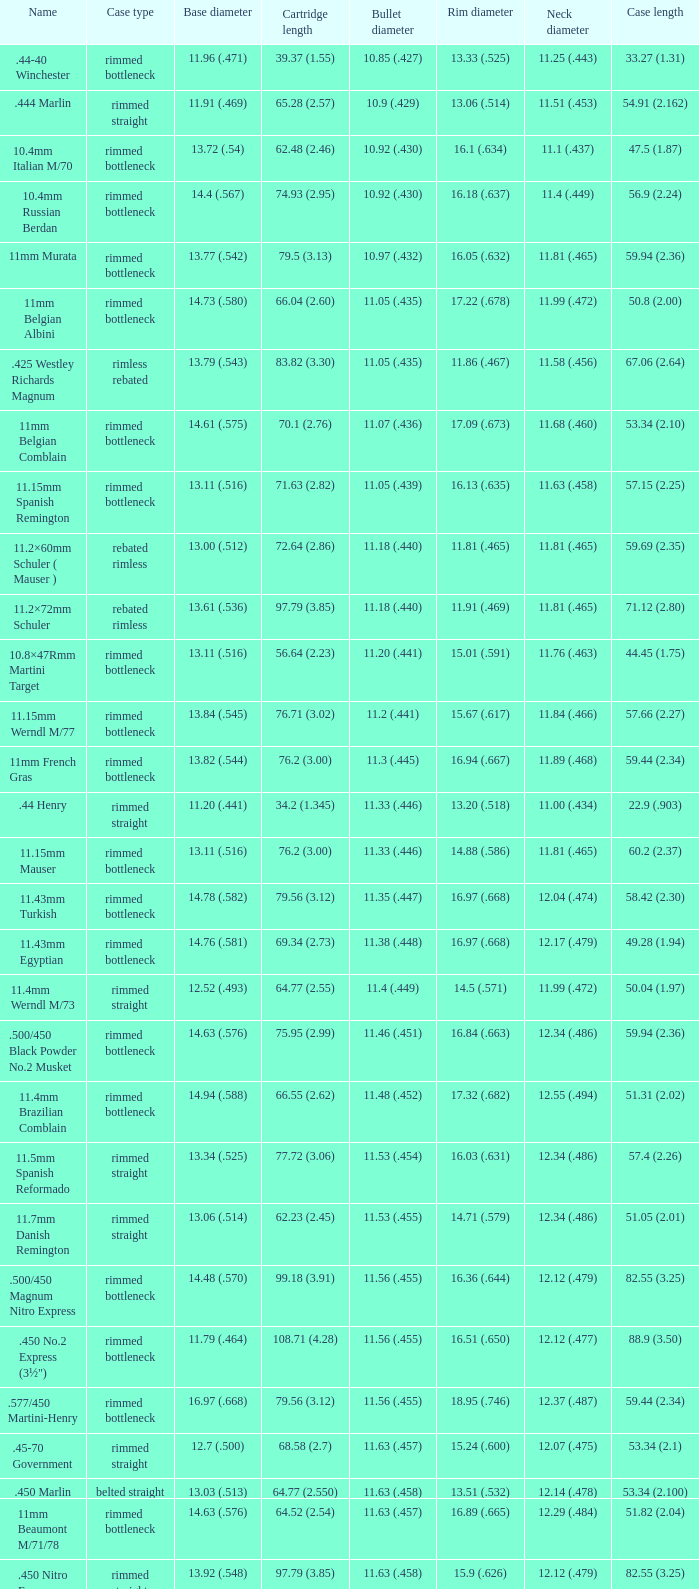Which Bullet diameter has a Name of 11.4mm werndl m/73? 11.4 (.449). 